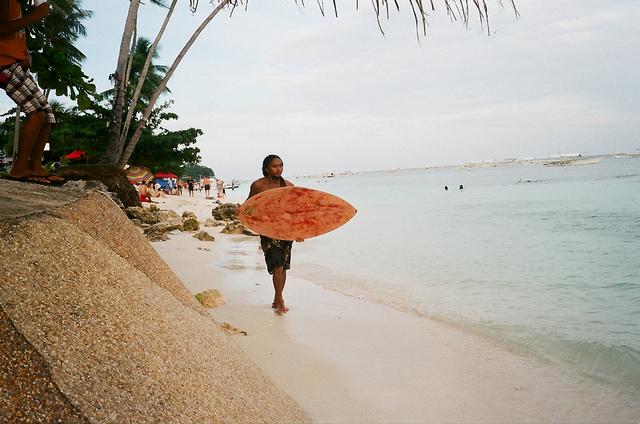What is the person holding in his hand?
Concise answer only. Surfboard. Does it snow here?
Short answer required. No. Is this man about to go to work in an office?
Write a very short answer. No. 